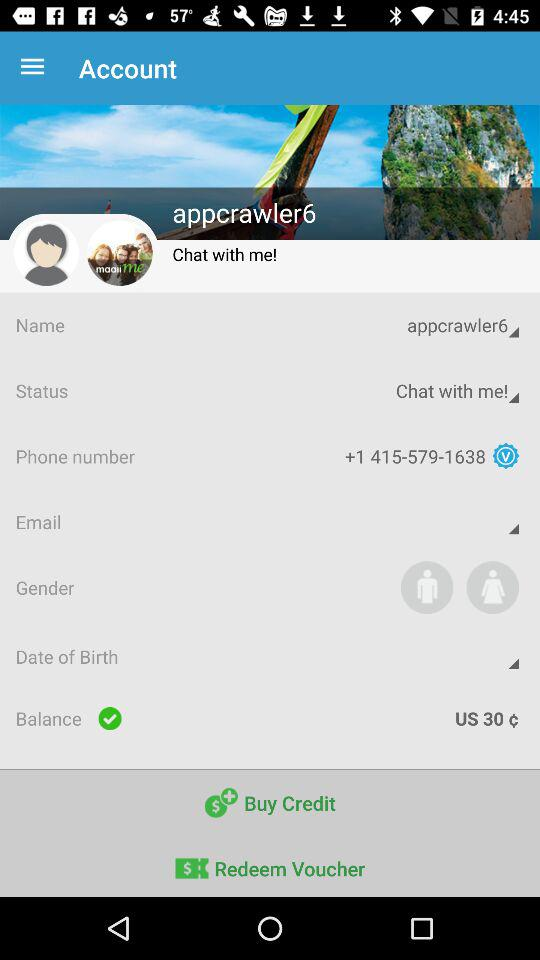What is the status? The status is "Chat with me!". 